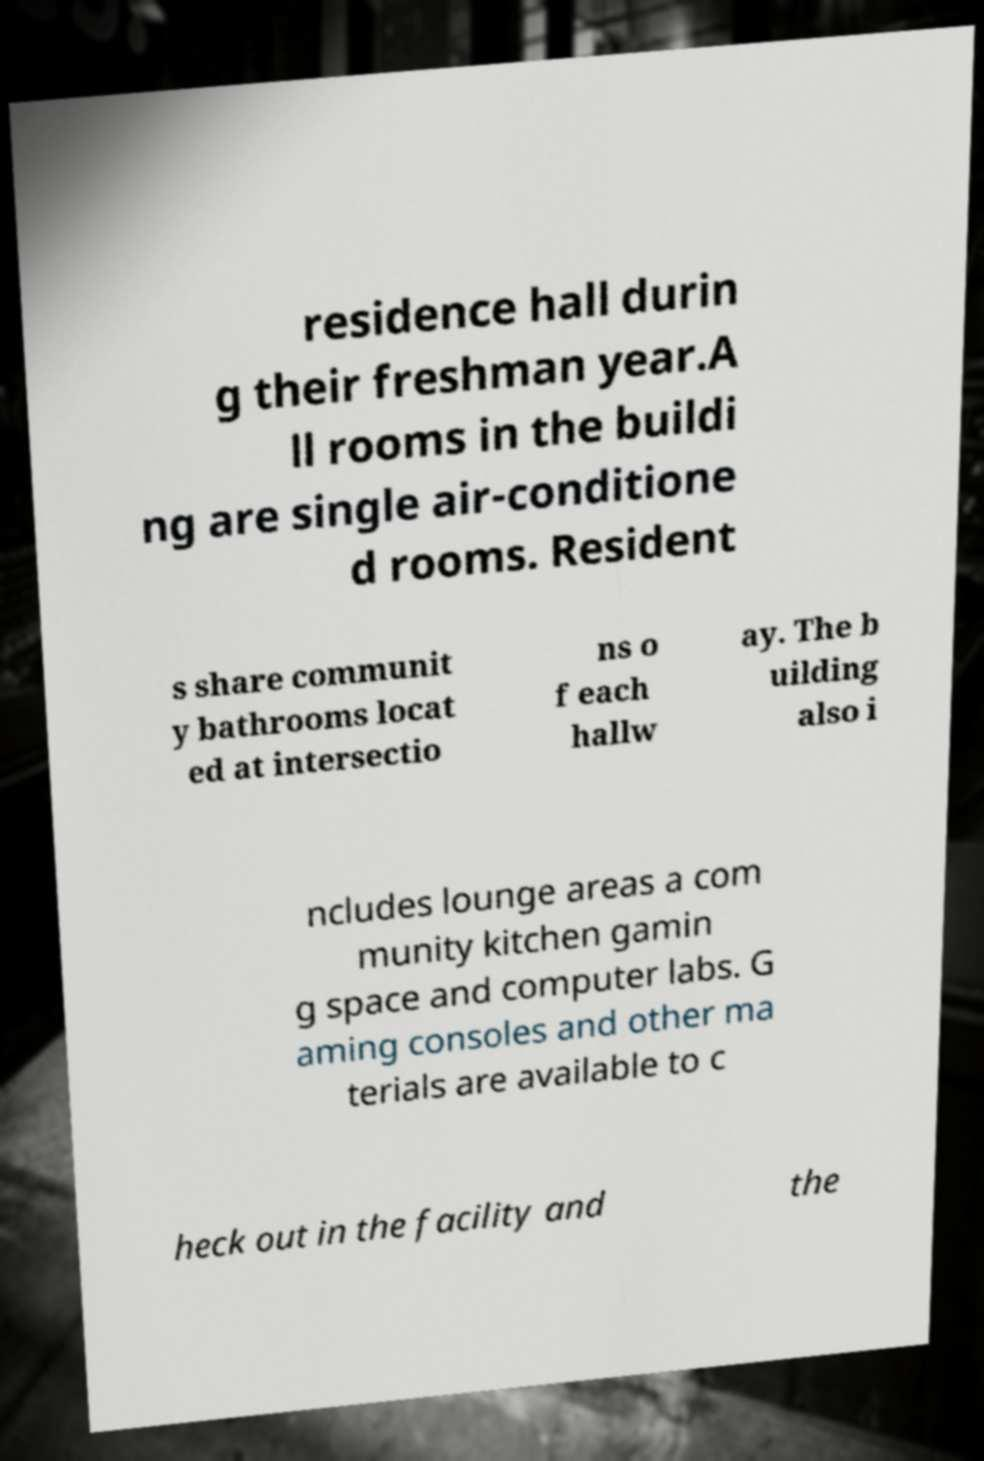Could you extract and type out the text from this image? residence hall durin g their freshman year.A ll rooms in the buildi ng are single air-conditione d rooms. Resident s share communit y bathrooms locat ed at intersectio ns o f each hallw ay. The b uilding also i ncludes lounge areas a com munity kitchen gamin g space and computer labs. G aming consoles and other ma terials are available to c heck out in the facility and the 